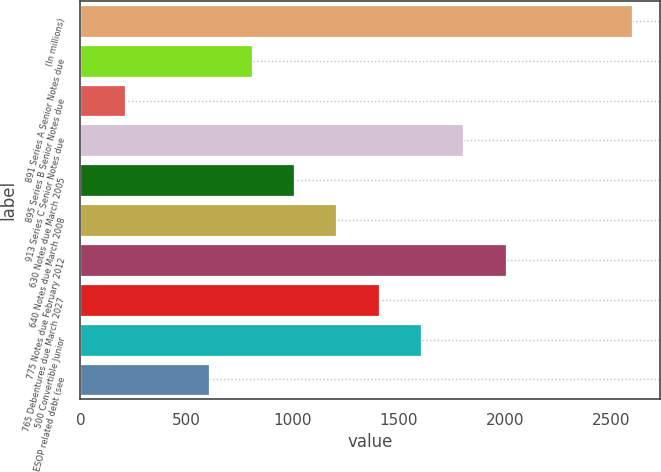Convert chart. <chart><loc_0><loc_0><loc_500><loc_500><bar_chart><fcel>(In millions)<fcel>891 Series A Senior Notes due<fcel>895 Series B Senior Notes due<fcel>913 Series C Senior Notes due<fcel>630 Notes due March 2005<fcel>640 Notes due March 2008<fcel>775 Notes due February 2012<fcel>765 Debentures due March 2027<fcel>500 Convertible Junior<fcel>ESOP related debt (see<nl><fcel>2600.84<fcel>807.32<fcel>209.48<fcel>1803.72<fcel>1006.6<fcel>1205.88<fcel>2003<fcel>1405.16<fcel>1604.44<fcel>608.04<nl></chart> 